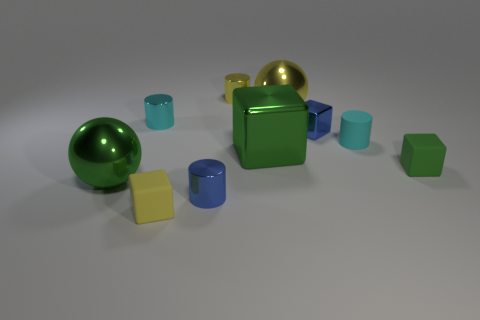Subtract 1 cylinders. How many cylinders are left? 3 Subtract all small blocks. How many blocks are left? 1 Subtract all purple cylinders. Subtract all purple cubes. How many cylinders are left? 4 Subtract all balls. How many objects are left? 8 Subtract 0 purple balls. How many objects are left? 10 Subtract all big purple metallic cubes. Subtract all cyan metallic cylinders. How many objects are left? 9 Add 8 tiny green rubber cubes. How many tiny green rubber cubes are left? 9 Add 8 yellow rubber cubes. How many yellow rubber cubes exist? 9 